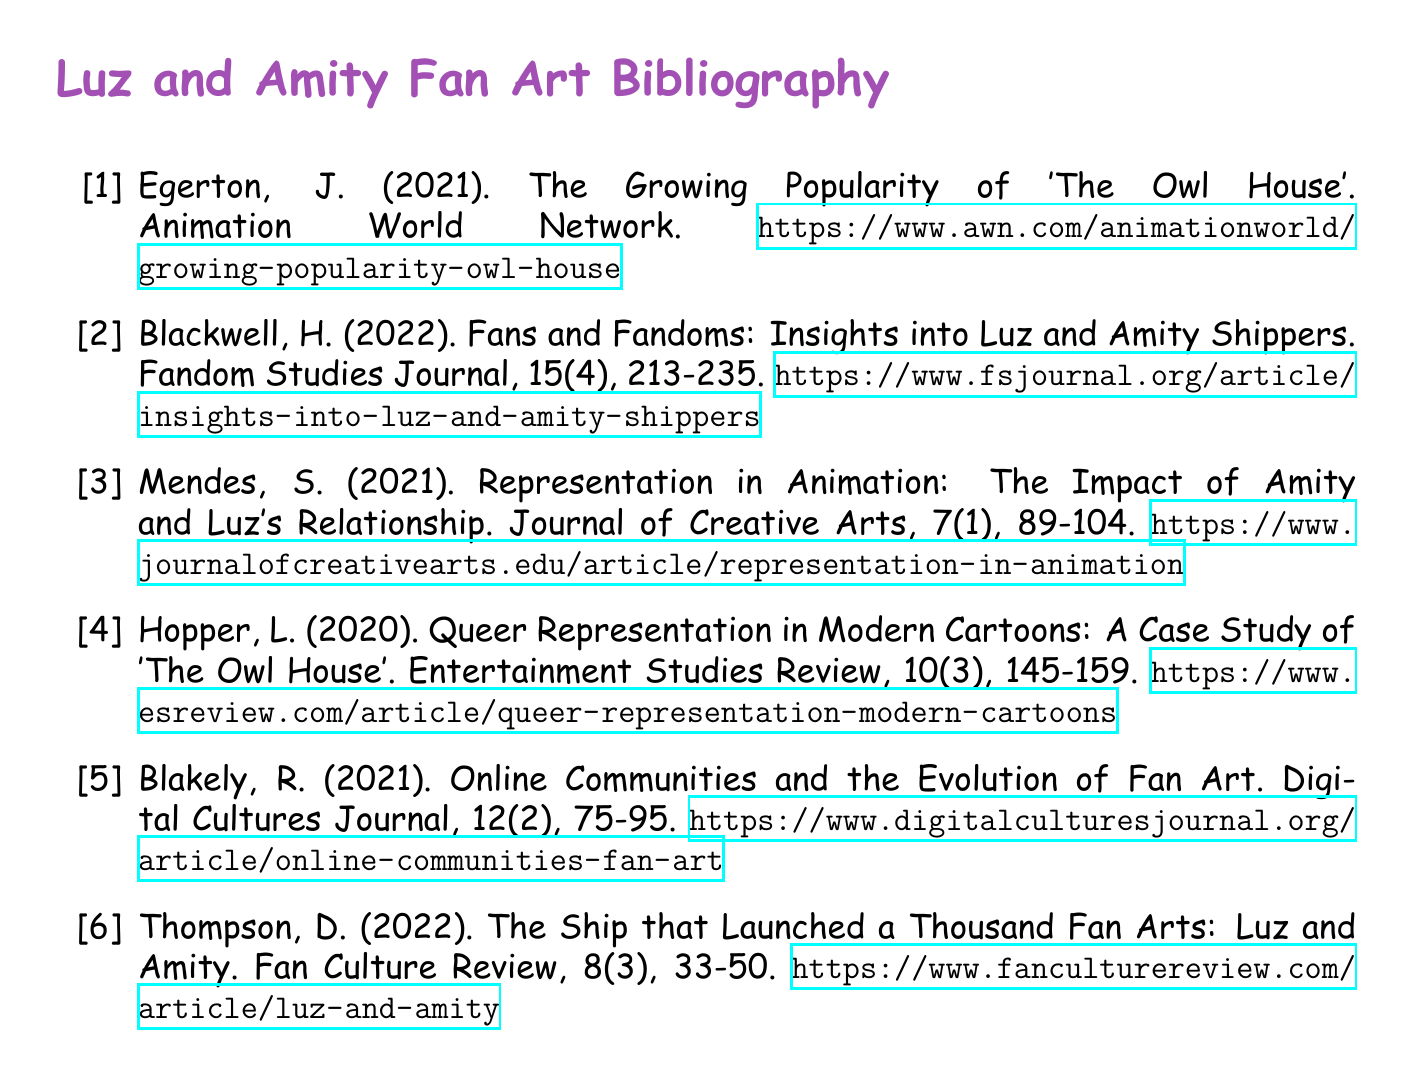What is the title of the article by J. Egerton? The title of the article is listed under the entry for J. Egerton in the bibliography.
Answer: The Growing Popularity of 'The Owl House' What year was the article by H. Blackwell published? The publication year can be found in the bibliographic entry for H. Blackwell.
Answer: 2022 Who is the author of "Queer Representation in Modern Cartoons"? The author's name is given in the bibliography entry related to the topic of queer representation.
Answer: L. Hopper What volume number is the article by S. Mendes published in? The volume number can be found in the bibliographic entry for S. Mendes.
Answer: 7 Which journal published the article about Luz and Amity by D. Thompson? The name of the journal can be found in the bibliography entry for D. Thompson.
Answer: Fan Culture Review What is the primary focus of the article by R. Blakely? The primary focus is discerned from the title and the context of the publication noted in the bibliography.
Answer: Online Communities and the Evolution of Fan Art What type of studies does the journal of H. Blackwell belong to? The type of studies is implied by the title of the journal mentioned in the bibliography.
Answer: Fandom Studies How many articles in the bibliography are published in 2021? The number of articles published in 2021 can be assessed by checking the years in the bibliography entries.
Answer: 3 What is the subtitle of the bibliography? The subtitle is indicated at the top of the bibliography section.
Answer: Luz and Amity Fan Art Bibliography 